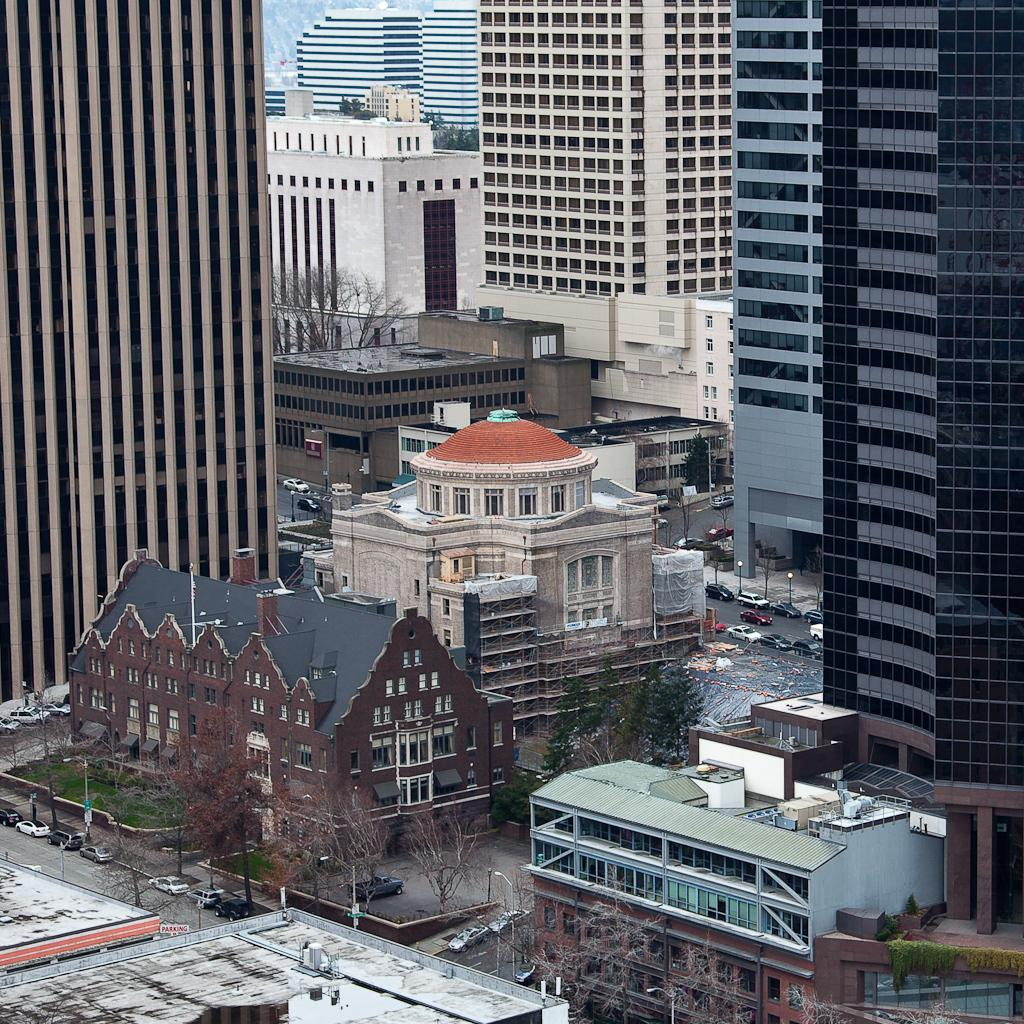What type of structures can be seen in the image? There are buildings and skyscrapers in the image. What else can be found in the image besides buildings? There are trees and poles in the image. Are there any vehicles visible in the image? Yes, there are vehicles parked on the road in the image. Where are the chickens and geese located in the image? There are no chickens or geese present in the image. What type of oil can be seen dripping from the skyscrapers in the image? There is no oil visible in the image, and the skyscrapers are not dripping anything. 